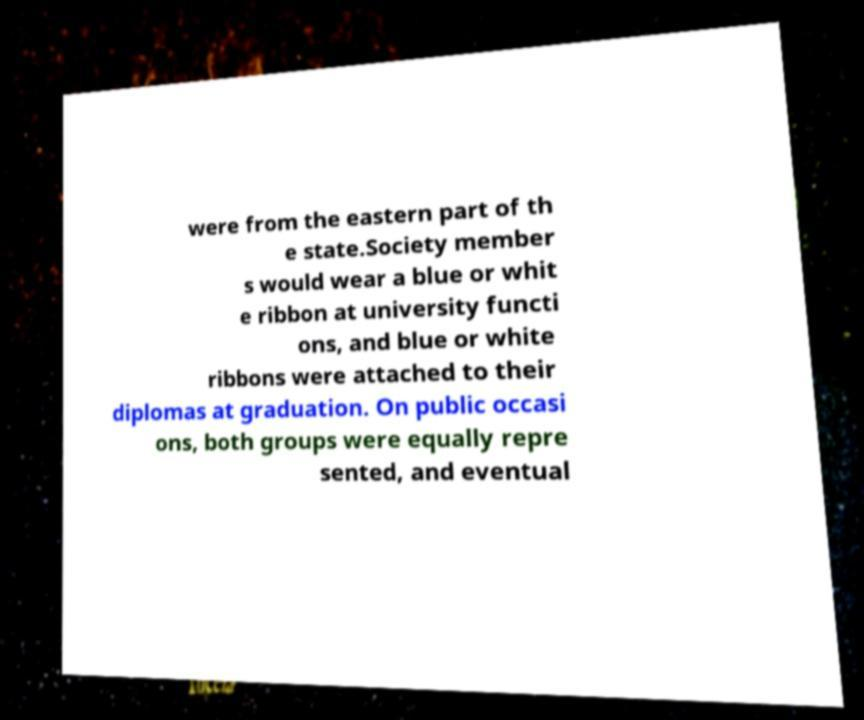For documentation purposes, I need the text within this image transcribed. Could you provide that? were from the eastern part of th e state.Society member s would wear a blue or whit e ribbon at university functi ons, and blue or white ribbons were attached to their diplomas at graduation. On public occasi ons, both groups were equally repre sented, and eventual 